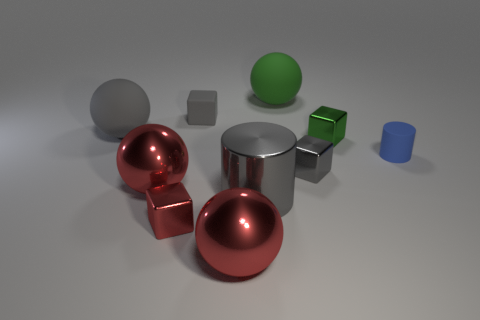Is there a rubber cube that is on the right side of the green object that is in front of the small rubber block?
Ensure brevity in your answer.  No. Is the number of big green matte objects on the left side of the metal cylinder less than the number of small red metal cubes behind the tiny red cube?
Your answer should be very brief. No. How big is the gray cube to the left of the tiny gray object that is to the right of the big ball that is in front of the red block?
Keep it short and to the point. Small. There is a cylinder that is in front of the blue rubber object; does it have the same size as the red cube?
Your response must be concise. No. How many other objects are there of the same material as the small blue cylinder?
Offer a very short reply. 3. Are there more gray metal things than cyan matte cubes?
Your answer should be very brief. Yes. The tiny gray object to the left of the green thing behind the small matte thing that is left of the rubber cylinder is made of what material?
Your answer should be very brief. Rubber. Does the big cylinder have the same color as the small matte cylinder?
Offer a very short reply. No. Are there any matte objects of the same color as the rubber cube?
Your response must be concise. Yes. The gray rubber thing that is the same size as the green rubber ball is what shape?
Provide a succinct answer. Sphere. 